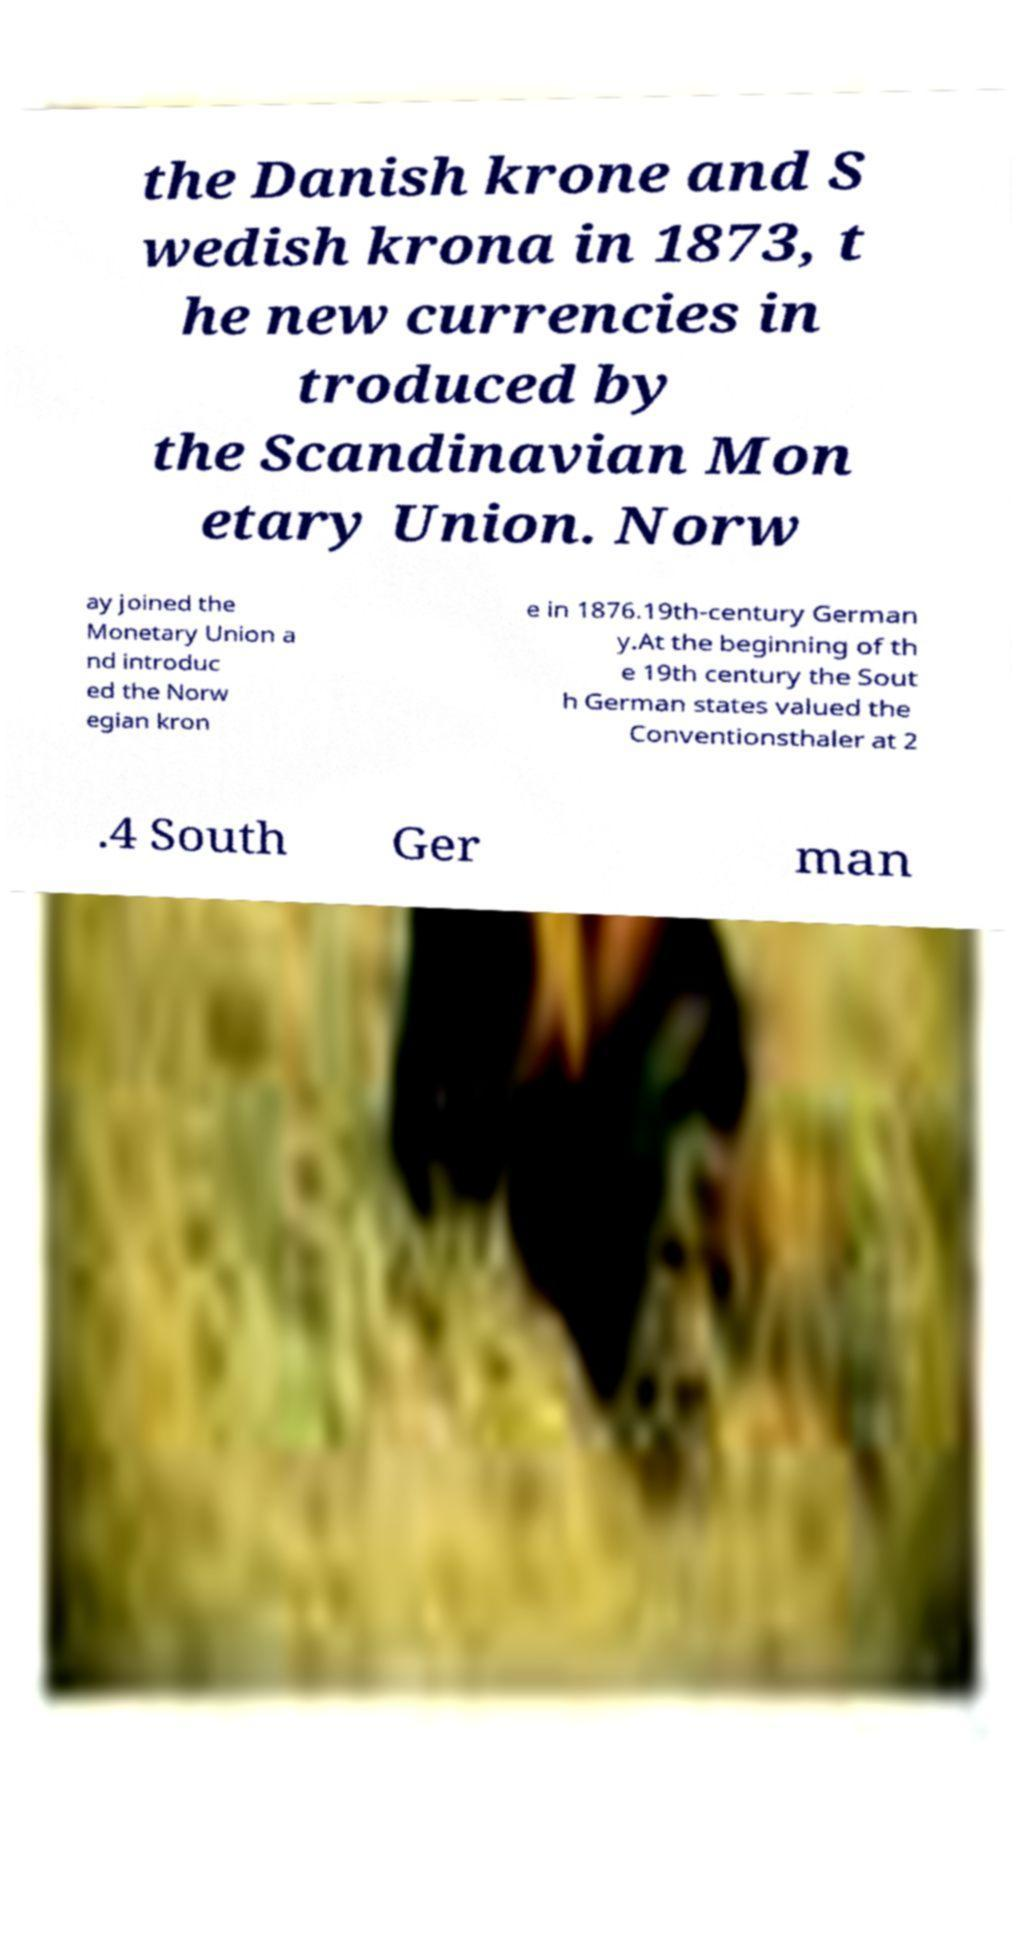Could you assist in decoding the text presented in this image and type it out clearly? the Danish krone and S wedish krona in 1873, t he new currencies in troduced by the Scandinavian Mon etary Union. Norw ay joined the Monetary Union a nd introduc ed the Norw egian kron e in 1876.19th-century German y.At the beginning of th e 19th century the Sout h German states valued the Conventionsthaler at 2 .4 South Ger man 